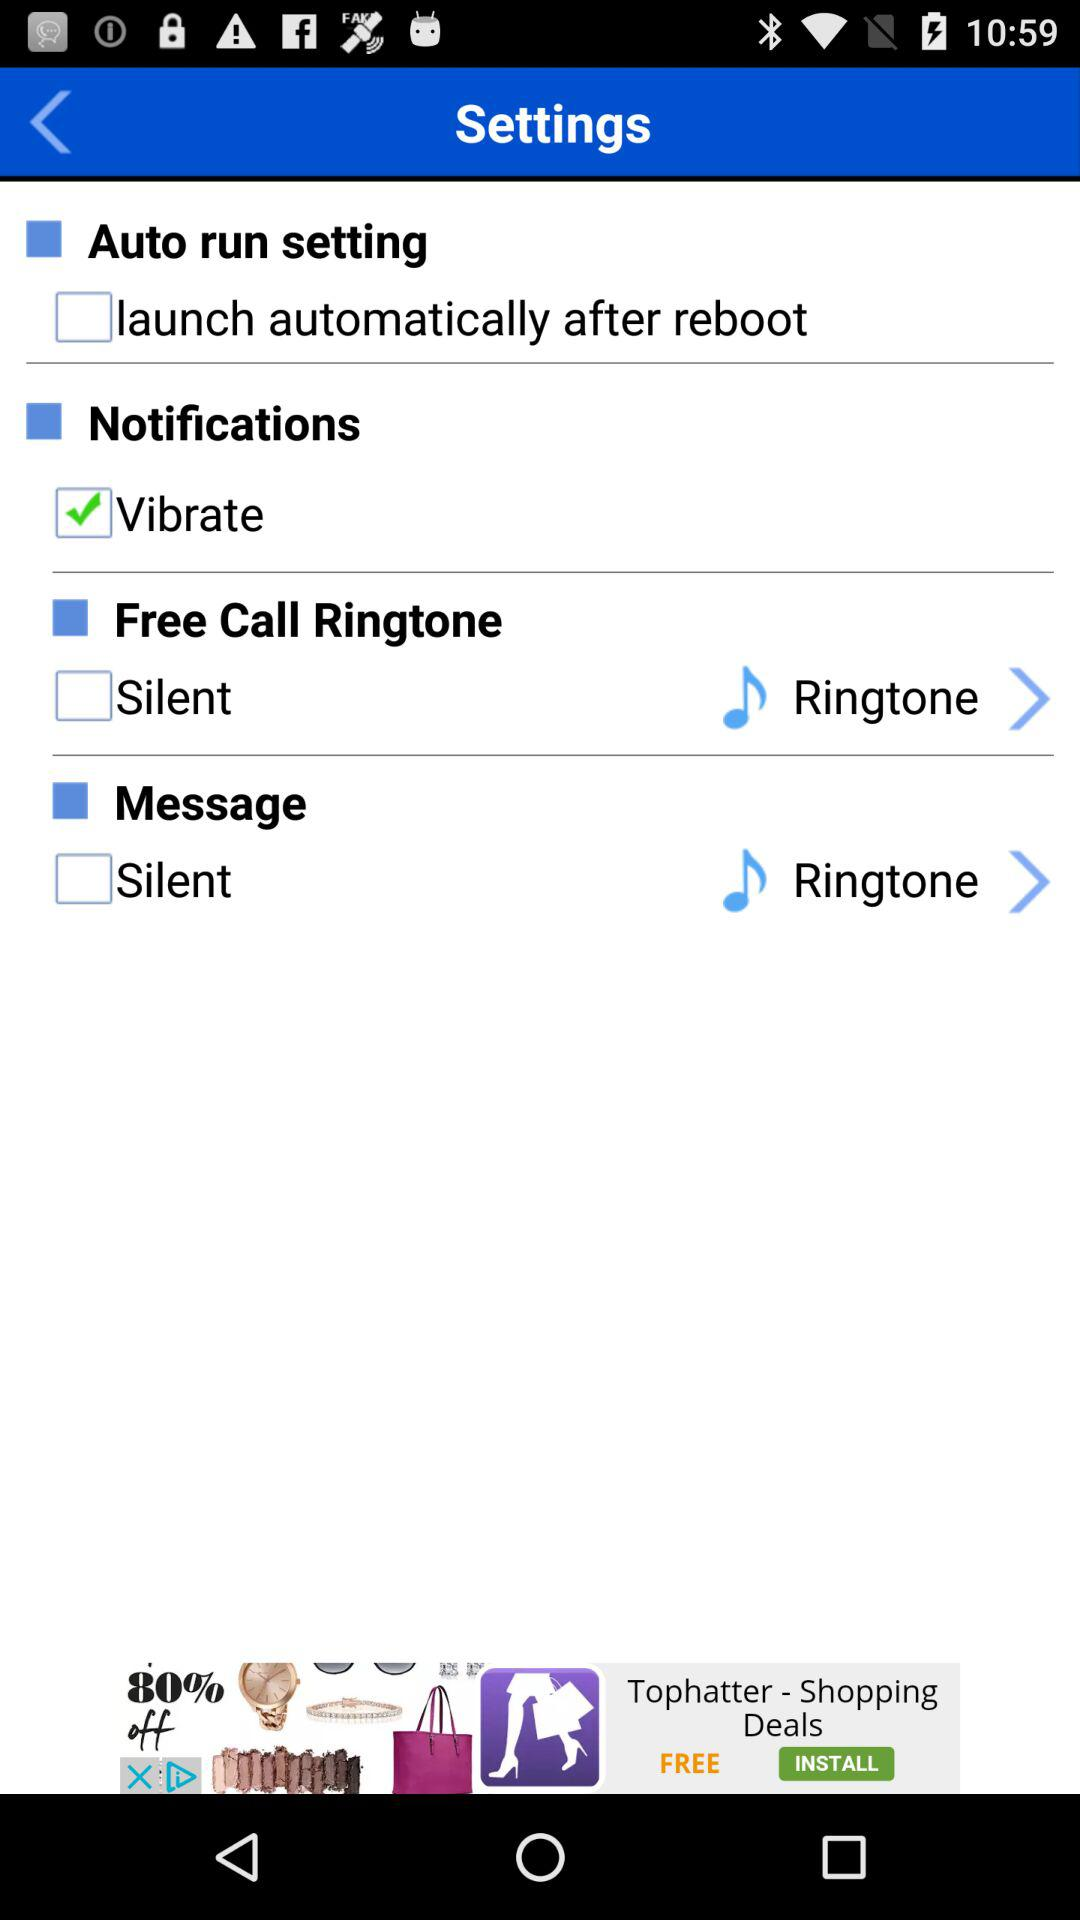What is another option to sign in? Another option to sign in is "Facebook". 